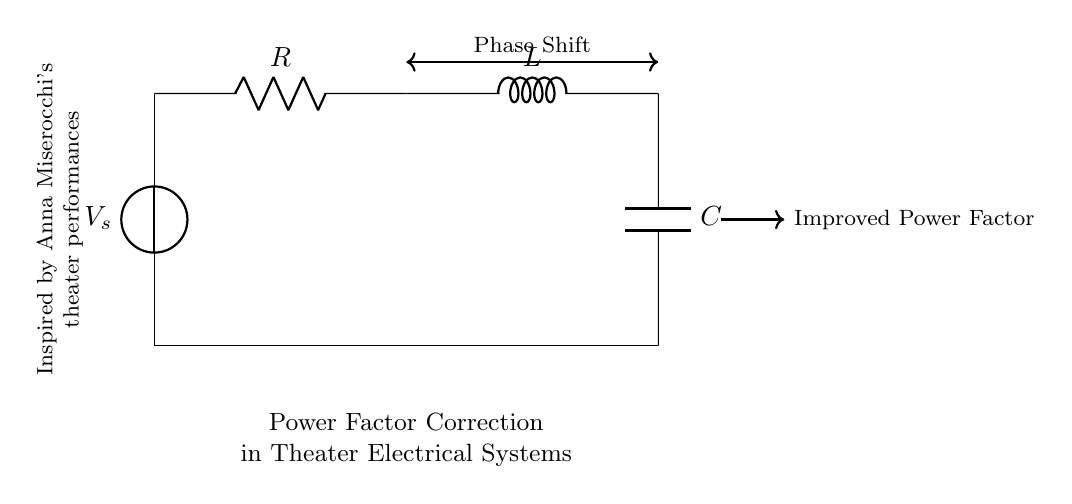What is the voltage source in this circuit? The voltage source is labeled as V_s, which represents the electrical potential supplied to the circuit.
Answer: V_s What type of passive components are used in this circuit? The circuit includes a resistor, an inductor, and a capacitor, which are all passive components commonly used in RLC circuits.
Answer: Resistor, Inductor, Capacitor What indicates power factor correction in this circuit? The note "Improved Power Factor" with the arrow pointing from the RLC components shows that the setup is designed to enhance the power factor.
Answer: Improved Power Factor How is the phase shift represented in this circuit? The phase shift is indicated by the double-headed arrow labeled "Phase Shift," suggesting that the current and voltage have a specific angular relationship due to the RLC configuration.
Answer: Phase Shift What is the relationship of components for power factor correction? The configuration of the resistor, inductor, and capacitor together adjusts the phase angle and reduces the reactive power, improving the overall power factor.
Answer: RLC configuration What is the main purpose of this RLC circuit in theater electrical systems? This RLC circuit's main purpose is to correct the power factor, making the electrical system more efficient by reducing losses associated with reactive power.
Answer: Power Factor Correction 